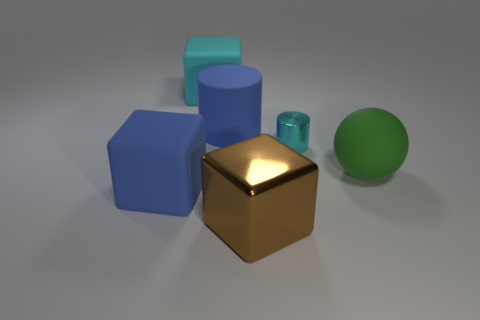What is the large blue object that is in front of the big matte thing to the right of the large cylinder made of? The large blue object appears to be a solid block, and given the context of the image which seems to be a 3D render, it's likely not made of real-world material. However, if we were to guess based on its appearance in the context of typical object materials, it might resemble a kind of plastic or perhaps a non-lustrous metal in a real-world setting. 